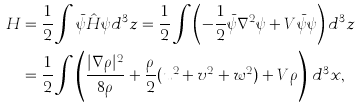Convert formula to latex. <formula><loc_0><loc_0><loc_500><loc_500>H & = \frac { 1 } { 2 } \int \bar { \psi } \hat { H } \psi d ^ { 3 } z = \frac { 1 } { 2 } \int \left ( - \frac { 1 } { 2 } \bar { \psi } \nabla ^ { 2 } \psi + V \bar { \psi } \psi \right ) d ^ { 3 } z \\ & = \frac { 1 } { 2 } \int \left ( \frac { | \nabla \rho | ^ { 2 } } { 8 \rho } + \frac { \rho } { 2 } ( u ^ { 2 } + v ^ { 2 } + w ^ { 2 } ) + V \rho \right ) \, d ^ { 3 } x ,</formula> 